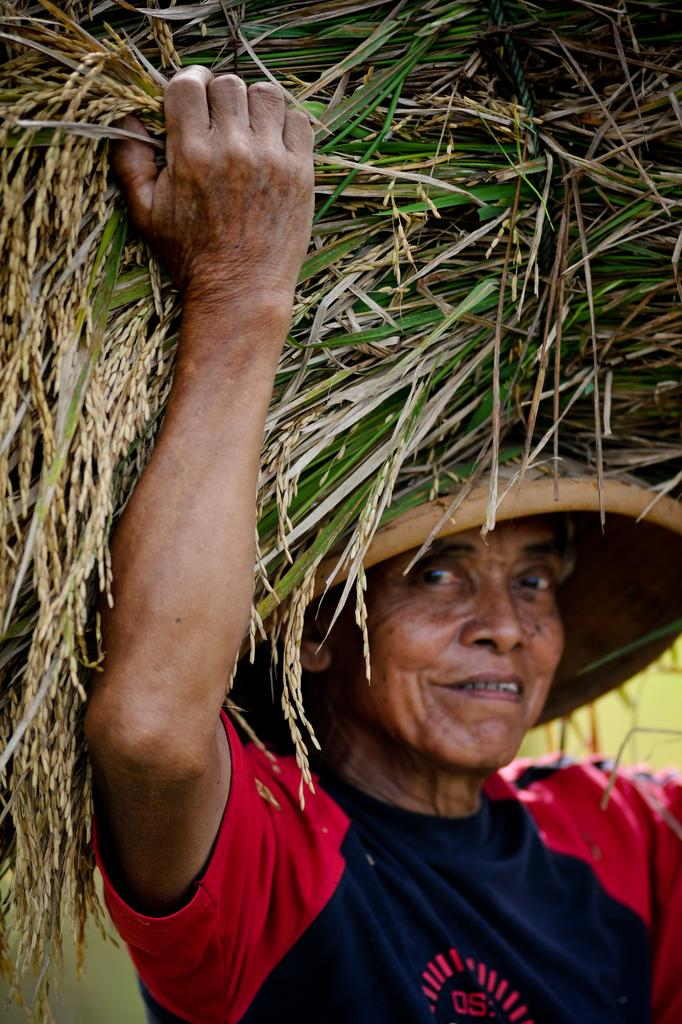What is present in the picture? There is a person in the picture. What is the person wearing? The person is wearing a red and black color T-shirt. What is the person doing in the picture? The person is carrying grass on their head. What type of yarn is the person using to hold the grass in the image? There is no yarn present in the image; the person is simply carrying grass on their head. 